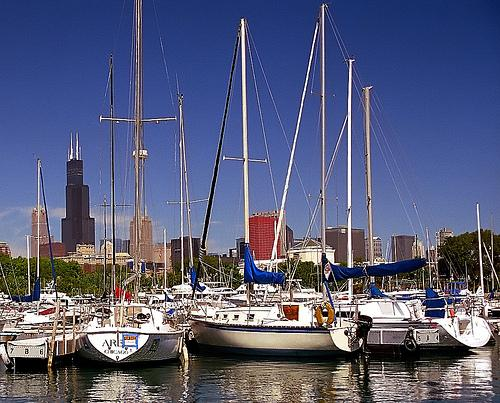Mention any interesting interactions between the objects in the image. Reflections of boat on water, ripples in the water caused by the boats, motor on a boat, and a for sale sign on a boat in the water are some interesting object interactions. Count the number of boats mentioned in the image description and specify their different colors. There are 5 boats mentioned, with colors white, blue, brown, and tan. What are the prominent colors visible in the given image? Blue, white, red, black, green, and brown are prominent colors in the image. Identify the main features visible in the image, such as objects and their characteristics. Boats, marina, reflections, masts, sails, white and blue colors, red, black, and brown buildings, blue sky, clouds, calm water, trees, antennas, and ripples in the water. Estimate the number of sailboats and their unique features described in the image. There are at least 3 sailboats, featuring a white mast, a blue sail, and a white mast with a blue sail cover. Create a brief narrative of the image setting based on the elements present. On a sunny day with a blue sky and a few clouds, boats are docked at a marina, surrounded by calm reflective water. There are red, black, and brown buildings nearby, with green trees in the background, and ripples spreading across the water's surface. Describe the different buildings in this image and their characteristics. There is a red building, a tall black building, a tall brown building, a smaller brick building, and another red building in the background, some of them with antennas on top. State the weather conditions in the image and describe the overall atmosphere of the scene. The weather is sunny with a few clouds scattered in the blue sky, and the atmosphere is calm and serene, highlighted by the reflective water surface in the marina. Explain the state of the water in the image and describe any relevant details. The water is calm and reflective, displaying boat reflections and having ripples in different parts of the scene. Analyze the sentiment of this image based on the objects present and the overall setting. The sentiment can be described as peaceful and relaxing, due to the calming waters, boats docked at the marina, and the presence of blue sky with a few clouds. Are the leaves on the trees turning yellow for fall? The leaves mentioned in the image are described as green, not yellow. Are the clouds in the sky dark and stormy? The clouds in the image are described as small, white clouds against a blue sky, not dark and stormy. Is there a large orange boat in the marina? There is a white boat and a brown and tan boat mentioned in the image, no large orange boat. Is the building beside the red building green? The tall brown building is beside the red building, not a green one. Can you see a yellow flag on the boat? The flag mentioned in the image is blue, not yellow. Is there a pink sail cover on the yacht? The sail cover mentioned in the image is blue, not pink. 